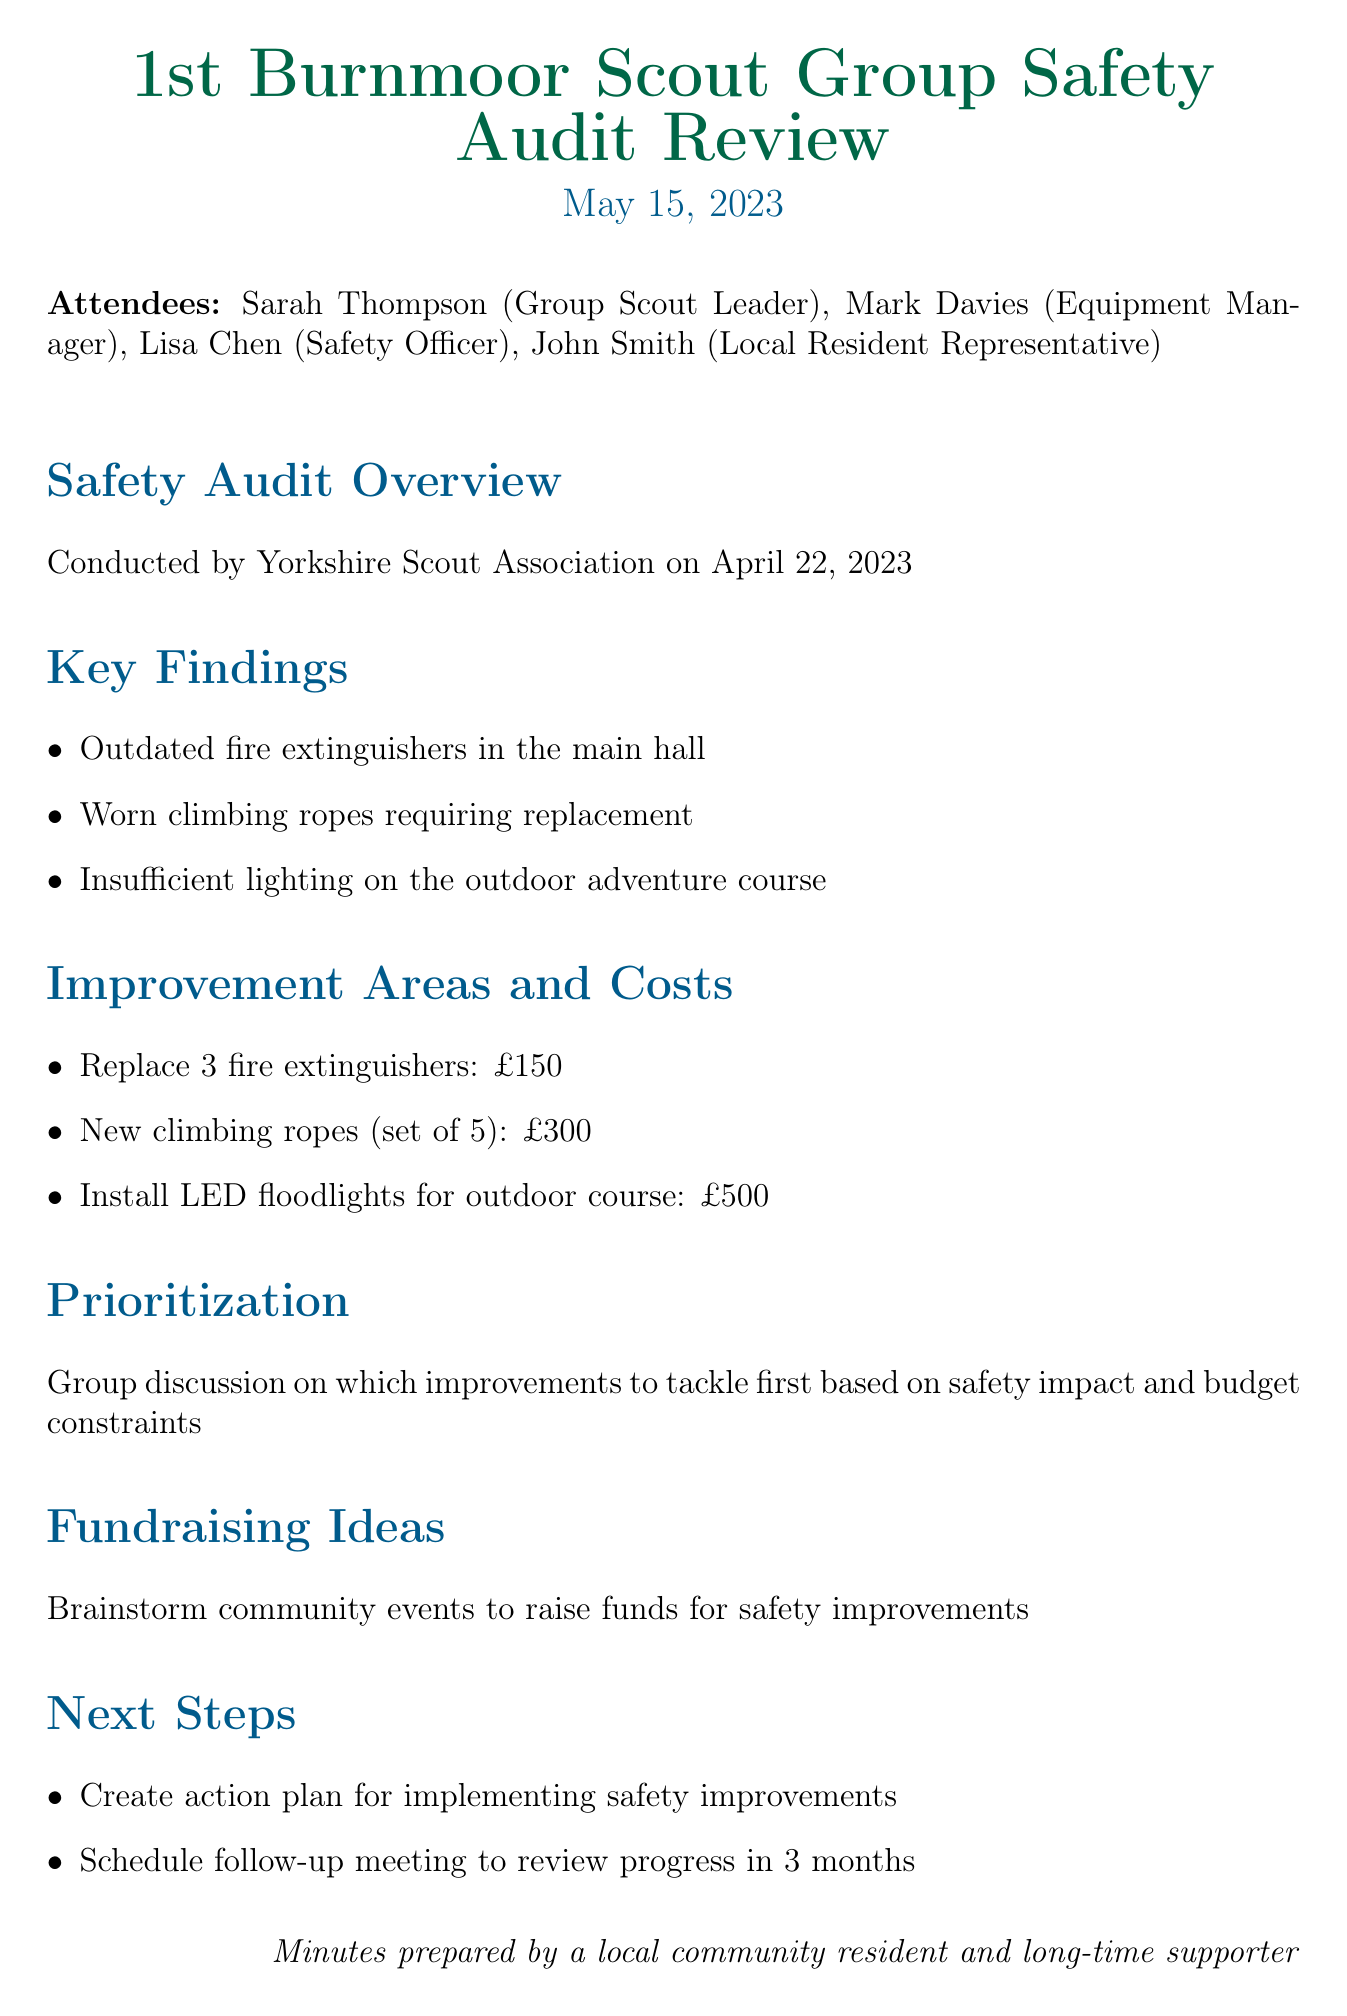What is the meeting date? The meeting date is explicitly stated in the document, which is May 15, 2023.
Answer: May 15, 2023 Who conducted the safety audit? The document mentions that the safety audit was conducted by the Yorkshire Scout Association.
Answer: Yorkshire Scout Association How many fire extinguishers need replacement? The key findings state that three fire extinguishers are outdated and require replacement.
Answer: 3 What is the total cost for replacing the climbing ropes? The document lists the cost for new climbing ropes (set of 5) as £300.
Answer: £300 What improvement area is prioritized based on safety impact? The document discusses prioritization based on safety impact and budget constraints, but does not specify one improvement area.
Answer: None specified What event type was discussed for fundraising? The document notes that there was a brainstorming session for community events to raise funds for safety improvements.
Answer: Community events When is the follow-up meeting scheduled? The document mentions a plan to schedule a follow-up meeting to review progress in 3 months, but a specific date is not provided.
Answer: In 3 months 